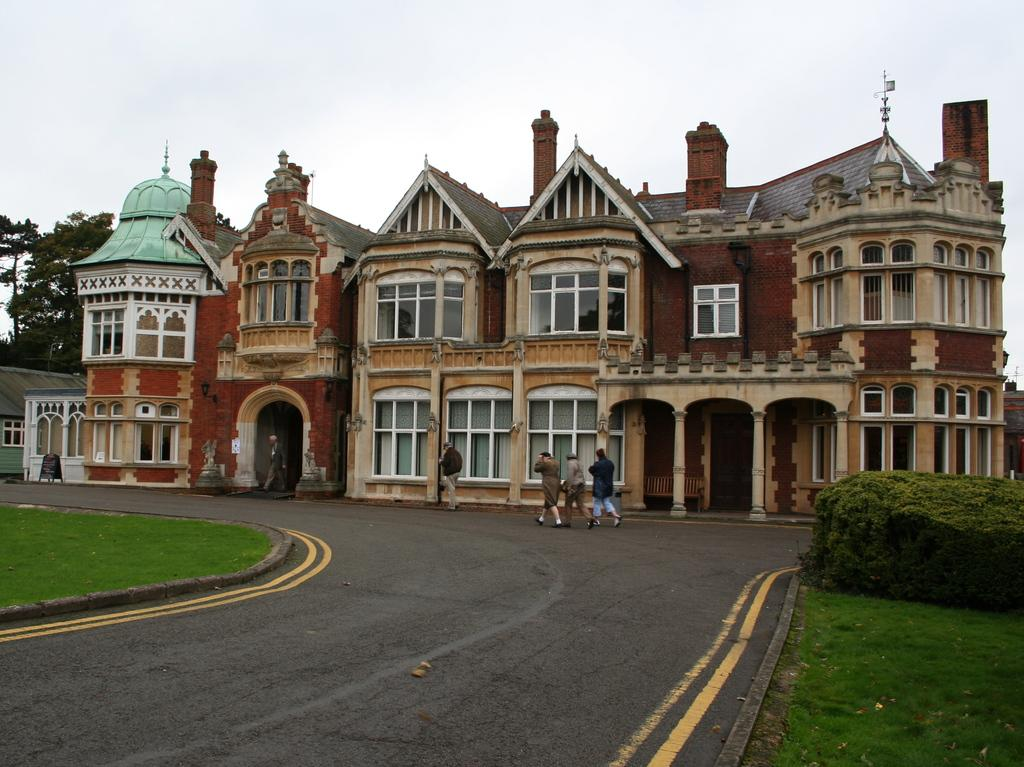What is happening in the center of the image? There is a group of people standing in the center of the image. What is the surface on which the people are standing? The people are standing on the ground. What can be seen in the background of the image? There is a building with multiple windows and pillars, as well as trees and the sky. How many jars can be seen gripped by the people in the image? There are no jars present in the image, and the people are not gripping anything. What type of print is visible on the building in the background? There is no print visible on the building in the background; it is a solid structure with windows and pillars. 